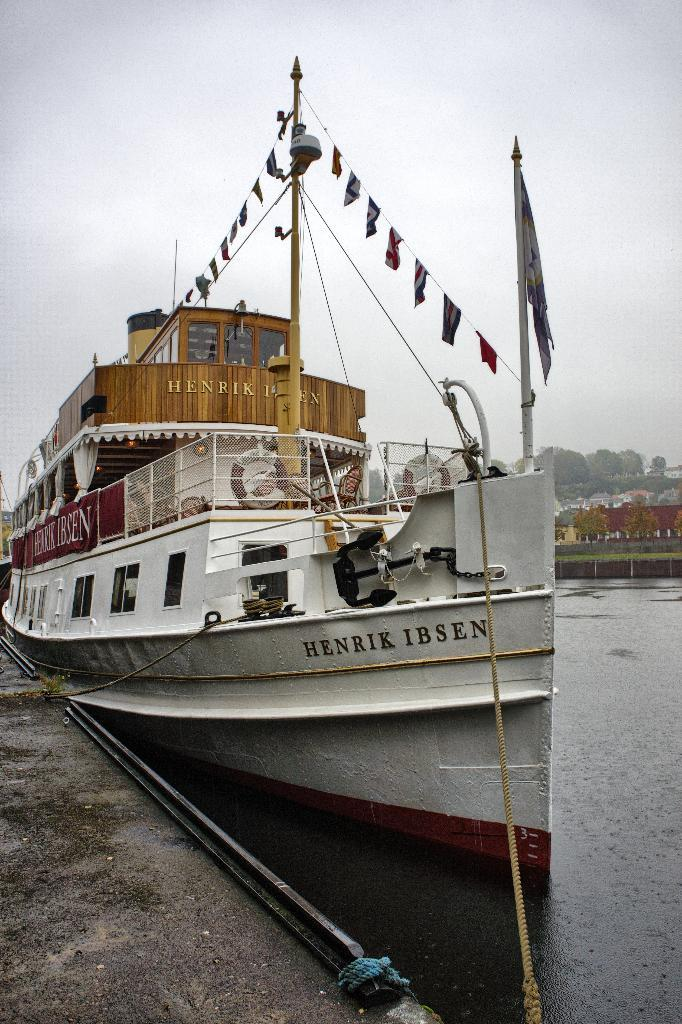What is the main subject in the foreground of the image? There is a boat in the water in the foreground. What additional items can be seen in the image? Ribbons, ropes, a flag pole, a fence, water, trees, buildings, a bridge, and the sky are visible in the image. What type of structure is present near the water? There is a bridge in the image. What can be inferred about the time of day when the image was taken? The image was likely taken during the day, as the sky is visible. What type of quill is being used to write on the boat in the image? There is no quill present in the image, and no writing activity is taking place on the boat. What crime is being committed in the image? There is no crime being committed in the image; it depicts a boat in the water, surrounded by various structures and objects. 